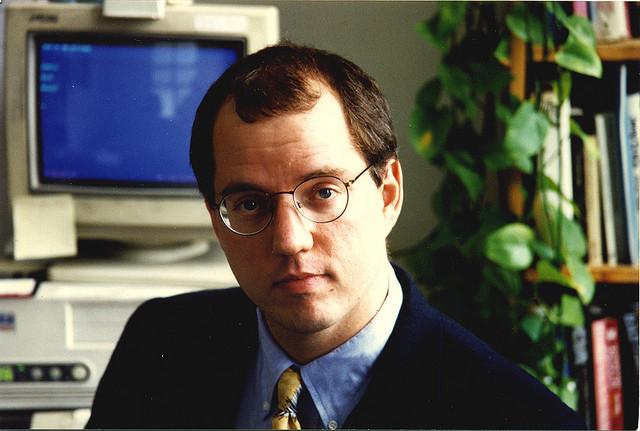Does this man have glasses on?
Keep it brief. Yes. How many bookshelves are visible?
Write a very short answer. 1. What is on the wall directly behind the man?
Keep it brief. Monitor. What type of computers are in the picture?
Quick response, please. Ibm. Is there a computer in the background?
Write a very short answer. Yes. 